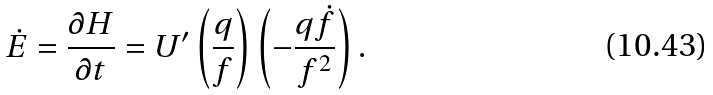<formula> <loc_0><loc_0><loc_500><loc_500>\dot { E } = \frac { \partial H } { \partial t } = U ^ { \prime } \left ( \frac { q } { f } \right ) \left ( - \frac { q \dot { f } } { f ^ { 2 } } \right ) .</formula> 